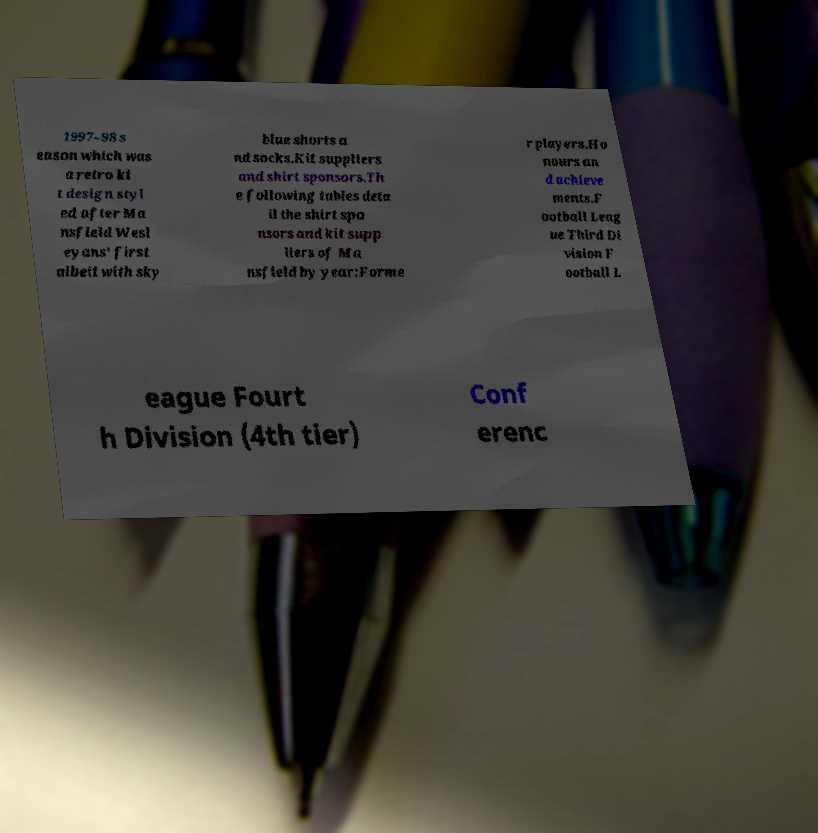I need the written content from this picture converted into text. Can you do that? 1997–98 s eason which was a retro ki t design styl ed after Ma nsfield Wesl eyans' first albeit with sky blue shorts a nd socks.Kit suppliers and shirt sponsors.Th e following tables deta il the shirt spo nsors and kit supp liers of Ma nsfield by year:Forme r players.Ho nours an d achieve ments.F ootball Leag ue Third Di vision F ootball L eague Fourt h Division (4th tier) Conf erenc 